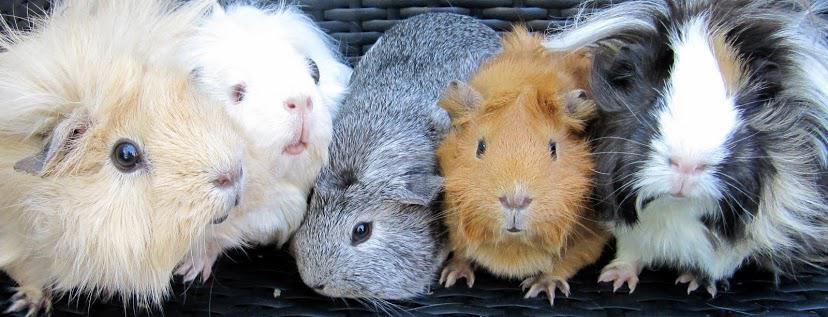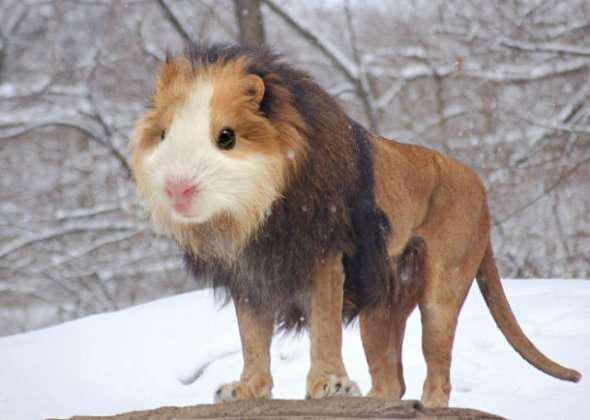The first image is the image on the left, the second image is the image on the right. Examine the images to the left and right. Is the description "One image shows real guinea pigs of various types with different fur styles, and the other image contains just one figure with a guinea pig face." accurate? Answer yes or no. Yes. 